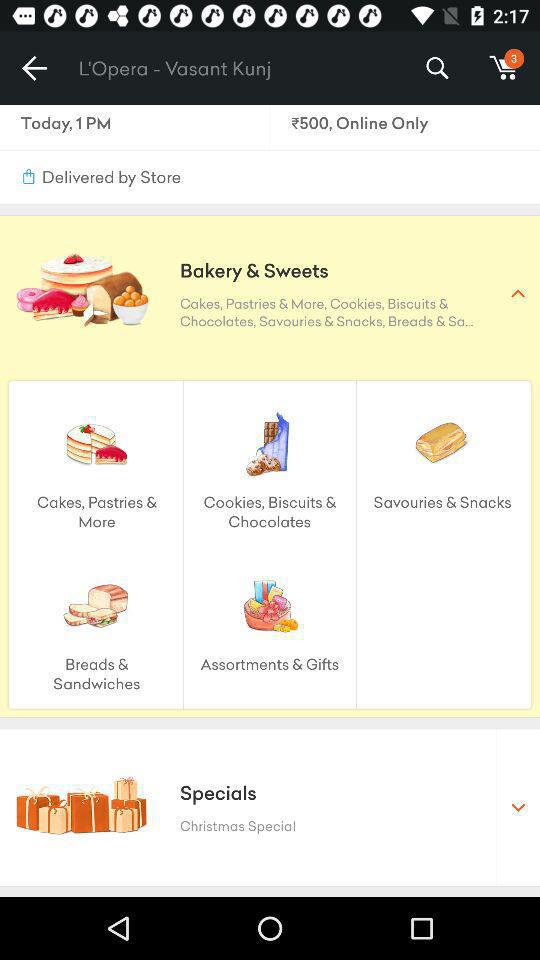Which types of "Specials" are there? The type is "Christmas Special". 